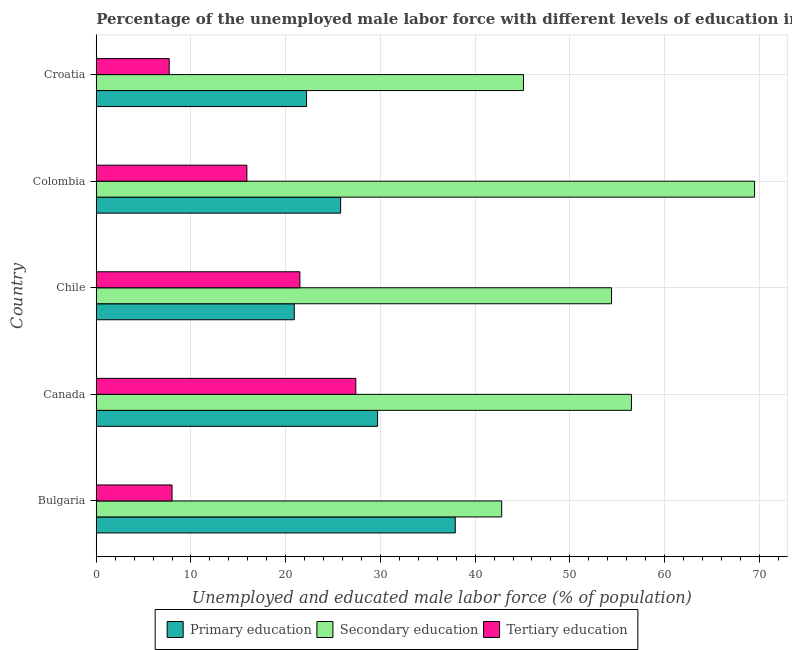How many different coloured bars are there?
Make the answer very short. 3. How many groups of bars are there?
Your answer should be compact. 5. How many bars are there on the 5th tick from the top?
Give a very brief answer. 3. What is the label of the 1st group of bars from the top?
Offer a terse response. Croatia. In how many cases, is the number of bars for a given country not equal to the number of legend labels?
Make the answer very short. 0. What is the percentage of male labor force who received tertiary education in Canada?
Provide a succinct answer. 27.4. Across all countries, what is the maximum percentage of male labor force who received primary education?
Give a very brief answer. 37.9. Across all countries, what is the minimum percentage of male labor force who received secondary education?
Ensure brevity in your answer.  42.8. In which country was the percentage of male labor force who received tertiary education minimum?
Offer a terse response. Croatia. What is the total percentage of male labor force who received tertiary education in the graph?
Provide a short and direct response. 80.5. What is the difference between the percentage of male labor force who received tertiary education in Colombia and the percentage of male labor force who received primary education in Croatia?
Offer a very short reply. -6.3. What is the average percentage of male labor force who received primary education per country?
Your answer should be compact. 27.3. What is the difference between the percentage of male labor force who received tertiary education and percentage of male labor force who received secondary education in Colombia?
Your answer should be compact. -53.6. What is the ratio of the percentage of male labor force who received primary education in Bulgaria to that in Croatia?
Your answer should be very brief. 1.71. What is the difference between the highest and the lowest percentage of male labor force who received primary education?
Your answer should be compact. 17. In how many countries, is the percentage of male labor force who received secondary education greater than the average percentage of male labor force who received secondary education taken over all countries?
Your response must be concise. 3. What does the 2nd bar from the bottom in Canada represents?
Ensure brevity in your answer.  Secondary education. Is it the case that in every country, the sum of the percentage of male labor force who received primary education and percentage of male labor force who received secondary education is greater than the percentage of male labor force who received tertiary education?
Offer a terse response. Yes. How many bars are there?
Offer a terse response. 15. Are all the bars in the graph horizontal?
Make the answer very short. Yes. What is the difference between two consecutive major ticks on the X-axis?
Your response must be concise. 10. Are the values on the major ticks of X-axis written in scientific E-notation?
Provide a succinct answer. No. Where does the legend appear in the graph?
Provide a succinct answer. Bottom center. How many legend labels are there?
Your answer should be very brief. 3. How are the legend labels stacked?
Offer a terse response. Horizontal. What is the title of the graph?
Offer a terse response. Percentage of the unemployed male labor force with different levels of education in countries. What is the label or title of the X-axis?
Ensure brevity in your answer.  Unemployed and educated male labor force (% of population). What is the Unemployed and educated male labor force (% of population) in Primary education in Bulgaria?
Offer a terse response. 37.9. What is the Unemployed and educated male labor force (% of population) in Secondary education in Bulgaria?
Give a very brief answer. 42.8. What is the Unemployed and educated male labor force (% of population) in Tertiary education in Bulgaria?
Offer a very short reply. 8. What is the Unemployed and educated male labor force (% of population) in Primary education in Canada?
Your answer should be very brief. 29.7. What is the Unemployed and educated male labor force (% of population) in Secondary education in Canada?
Ensure brevity in your answer.  56.5. What is the Unemployed and educated male labor force (% of population) in Tertiary education in Canada?
Keep it short and to the point. 27.4. What is the Unemployed and educated male labor force (% of population) in Primary education in Chile?
Give a very brief answer. 20.9. What is the Unemployed and educated male labor force (% of population) in Secondary education in Chile?
Your response must be concise. 54.4. What is the Unemployed and educated male labor force (% of population) in Primary education in Colombia?
Your answer should be compact. 25.8. What is the Unemployed and educated male labor force (% of population) of Secondary education in Colombia?
Provide a short and direct response. 69.5. What is the Unemployed and educated male labor force (% of population) in Tertiary education in Colombia?
Provide a short and direct response. 15.9. What is the Unemployed and educated male labor force (% of population) in Primary education in Croatia?
Provide a succinct answer. 22.2. What is the Unemployed and educated male labor force (% of population) of Secondary education in Croatia?
Ensure brevity in your answer.  45.1. What is the Unemployed and educated male labor force (% of population) in Tertiary education in Croatia?
Give a very brief answer. 7.7. Across all countries, what is the maximum Unemployed and educated male labor force (% of population) of Primary education?
Your answer should be very brief. 37.9. Across all countries, what is the maximum Unemployed and educated male labor force (% of population) in Secondary education?
Make the answer very short. 69.5. Across all countries, what is the maximum Unemployed and educated male labor force (% of population) of Tertiary education?
Give a very brief answer. 27.4. Across all countries, what is the minimum Unemployed and educated male labor force (% of population) of Primary education?
Give a very brief answer. 20.9. Across all countries, what is the minimum Unemployed and educated male labor force (% of population) in Secondary education?
Your answer should be compact. 42.8. Across all countries, what is the minimum Unemployed and educated male labor force (% of population) in Tertiary education?
Your response must be concise. 7.7. What is the total Unemployed and educated male labor force (% of population) in Primary education in the graph?
Provide a short and direct response. 136.5. What is the total Unemployed and educated male labor force (% of population) in Secondary education in the graph?
Offer a terse response. 268.3. What is the total Unemployed and educated male labor force (% of population) of Tertiary education in the graph?
Offer a terse response. 80.5. What is the difference between the Unemployed and educated male labor force (% of population) in Secondary education in Bulgaria and that in Canada?
Offer a very short reply. -13.7. What is the difference between the Unemployed and educated male labor force (% of population) of Tertiary education in Bulgaria and that in Canada?
Provide a succinct answer. -19.4. What is the difference between the Unemployed and educated male labor force (% of population) of Tertiary education in Bulgaria and that in Chile?
Your response must be concise. -13.5. What is the difference between the Unemployed and educated male labor force (% of population) of Secondary education in Bulgaria and that in Colombia?
Provide a succinct answer. -26.7. What is the difference between the Unemployed and educated male labor force (% of population) in Tertiary education in Bulgaria and that in Croatia?
Offer a terse response. 0.3. What is the difference between the Unemployed and educated male labor force (% of population) of Secondary education in Canada and that in Chile?
Your answer should be compact. 2.1. What is the difference between the Unemployed and educated male labor force (% of population) in Tertiary education in Canada and that in Croatia?
Provide a succinct answer. 19.7. What is the difference between the Unemployed and educated male labor force (% of population) in Secondary education in Chile and that in Colombia?
Ensure brevity in your answer.  -15.1. What is the difference between the Unemployed and educated male labor force (% of population) of Primary education in Chile and that in Croatia?
Your answer should be compact. -1.3. What is the difference between the Unemployed and educated male labor force (% of population) in Secondary education in Colombia and that in Croatia?
Provide a succinct answer. 24.4. What is the difference between the Unemployed and educated male labor force (% of population) of Primary education in Bulgaria and the Unemployed and educated male labor force (% of population) of Secondary education in Canada?
Your answer should be very brief. -18.6. What is the difference between the Unemployed and educated male labor force (% of population) of Primary education in Bulgaria and the Unemployed and educated male labor force (% of population) of Secondary education in Chile?
Keep it short and to the point. -16.5. What is the difference between the Unemployed and educated male labor force (% of population) in Secondary education in Bulgaria and the Unemployed and educated male labor force (% of population) in Tertiary education in Chile?
Provide a succinct answer. 21.3. What is the difference between the Unemployed and educated male labor force (% of population) in Primary education in Bulgaria and the Unemployed and educated male labor force (% of population) in Secondary education in Colombia?
Ensure brevity in your answer.  -31.6. What is the difference between the Unemployed and educated male labor force (% of population) of Primary education in Bulgaria and the Unemployed and educated male labor force (% of population) of Tertiary education in Colombia?
Your answer should be compact. 22. What is the difference between the Unemployed and educated male labor force (% of population) in Secondary education in Bulgaria and the Unemployed and educated male labor force (% of population) in Tertiary education in Colombia?
Make the answer very short. 26.9. What is the difference between the Unemployed and educated male labor force (% of population) of Primary education in Bulgaria and the Unemployed and educated male labor force (% of population) of Tertiary education in Croatia?
Offer a terse response. 30.2. What is the difference between the Unemployed and educated male labor force (% of population) of Secondary education in Bulgaria and the Unemployed and educated male labor force (% of population) of Tertiary education in Croatia?
Provide a short and direct response. 35.1. What is the difference between the Unemployed and educated male labor force (% of population) of Primary education in Canada and the Unemployed and educated male labor force (% of population) of Secondary education in Chile?
Keep it short and to the point. -24.7. What is the difference between the Unemployed and educated male labor force (% of population) of Primary education in Canada and the Unemployed and educated male labor force (% of population) of Tertiary education in Chile?
Your answer should be compact. 8.2. What is the difference between the Unemployed and educated male labor force (% of population) of Secondary education in Canada and the Unemployed and educated male labor force (% of population) of Tertiary education in Chile?
Ensure brevity in your answer.  35. What is the difference between the Unemployed and educated male labor force (% of population) of Primary education in Canada and the Unemployed and educated male labor force (% of population) of Secondary education in Colombia?
Your response must be concise. -39.8. What is the difference between the Unemployed and educated male labor force (% of population) in Secondary education in Canada and the Unemployed and educated male labor force (% of population) in Tertiary education in Colombia?
Offer a terse response. 40.6. What is the difference between the Unemployed and educated male labor force (% of population) in Primary education in Canada and the Unemployed and educated male labor force (% of population) in Secondary education in Croatia?
Offer a terse response. -15.4. What is the difference between the Unemployed and educated male labor force (% of population) in Secondary education in Canada and the Unemployed and educated male labor force (% of population) in Tertiary education in Croatia?
Offer a very short reply. 48.8. What is the difference between the Unemployed and educated male labor force (% of population) in Primary education in Chile and the Unemployed and educated male labor force (% of population) in Secondary education in Colombia?
Give a very brief answer. -48.6. What is the difference between the Unemployed and educated male labor force (% of population) in Primary education in Chile and the Unemployed and educated male labor force (% of population) in Tertiary education in Colombia?
Your response must be concise. 5. What is the difference between the Unemployed and educated male labor force (% of population) in Secondary education in Chile and the Unemployed and educated male labor force (% of population) in Tertiary education in Colombia?
Offer a very short reply. 38.5. What is the difference between the Unemployed and educated male labor force (% of population) of Primary education in Chile and the Unemployed and educated male labor force (% of population) of Secondary education in Croatia?
Offer a very short reply. -24.2. What is the difference between the Unemployed and educated male labor force (% of population) of Secondary education in Chile and the Unemployed and educated male labor force (% of population) of Tertiary education in Croatia?
Provide a succinct answer. 46.7. What is the difference between the Unemployed and educated male labor force (% of population) in Primary education in Colombia and the Unemployed and educated male labor force (% of population) in Secondary education in Croatia?
Provide a succinct answer. -19.3. What is the difference between the Unemployed and educated male labor force (% of population) of Secondary education in Colombia and the Unemployed and educated male labor force (% of population) of Tertiary education in Croatia?
Your answer should be very brief. 61.8. What is the average Unemployed and educated male labor force (% of population) in Primary education per country?
Give a very brief answer. 27.3. What is the average Unemployed and educated male labor force (% of population) of Secondary education per country?
Provide a succinct answer. 53.66. What is the difference between the Unemployed and educated male labor force (% of population) in Primary education and Unemployed and educated male labor force (% of population) in Secondary education in Bulgaria?
Provide a short and direct response. -4.9. What is the difference between the Unemployed and educated male labor force (% of population) of Primary education and Unemployed and educated male labor force (% of population) of Tertiary education in Bulgaria?
Your response must be concise. 29.9. What is the difference between the Unemployed and educated male labor force (% of population) in Secondary education and Unemployed and educated male labor force (% of population) in Tertiary education in Bulgaria?
Offer a very short reply. 34.8. What is the difference between the Unemployed and educated male labor force (% of population) of Primary education and Unemployed and educated male labor force (% of population) of Secondary education in Canada?
Offer a terse response. -26.8. What is the difference between the Unemployed and educated male labor force (% of population) of Secondary education and Unemployed and educated male labor force (% of population) of Tertiary education in Canada?
Your answer should be very brief. 29.1. What is the difference between the Unemployed and educated male labor force (% of population) in Primary education and Unemployed and educated male labor force (% of population) in Secondary education in Chile?
Offer a terse response. -33.5. What is the difference between the Unemployed and educated male labor force (% of population) of Primary education and Unemployed and educated male labor force (% of population) of Tertiary education in Chile?
Your answer should be very brief. -0.6. What is the difference between the Unemployed and educated male labor force (% of population) of Secondary education and Unemployed and educated male labor force (% of population) of Tertiary education in Chile?
Make the answer very short. 32.9. What is the difference between the Unemployed and educated male labor force (% of population) of Primary education and Unemployed and educated male labor force (% of population) of Secondary education in Colombia?
Your response must be concise. -43.7. What is the difference between the Unemployed and educated male labor force (% of population) in Primary education and Unemployed and educated male labor force (% of population) in Tertiary education in Colombia?
Provide a succinct answer. 9.9. What is the difference between the Unemployed and educated male labor force (% of population) in Secondary education and Unemployed and educated male labor force (% of population) in Tertiary education in Colombia?
Offer a very short reply. 53.6. What is the difference between the Unemployed and educated male labor force (% of population) of Primary education and Unemployed and educated male labor force (% of population) of Secondary education in Croatia?
Offer a very short reply. -22.9. What is the difference between the Unemployed and educated male labor force (% of population) of Secondary education and Unemployed and educated male labor force (% of population) of Tertiary education in Croatia?
Your answer should be compact. 37.4. What is the ratio of the Unemployed and educated male labor force (% of population) of Primary education in Bulgaria to that in Canada?
Give a very brief answer. 1.28. What is the ratio of the Unemployed and educated male labor force (% of population) in Secondary education in Bulgaria to that in Canada?
Give a very brief answer. 0.76. What is the ratio of the Unemployed and educated male labor force (% of population) in Tertiary education in Bulgaria to that in Canada?
Provide a short and direct response. 0.29. What is the ratio of the Unemployed and educated male labor force (% of population) of Primary education in Bulgaria to that in Chile?
Your answer should be compact. 1.81. What is the ratio of the Unemployed and educated male labor force (% of population) in Secondary education in Bulgaria to that in Chile?
Provide a short and direct response. 0.79. What is the ratio of the Unemployed and educated male labor force (% of population) of Tertiary education in Bulgaria to that in Chile?
Provide a short and direct response. 0.37. What is the ratio of the Unemployed and educated male labor force (% of population) of Primary education in Bulgaria to that in Colombia?
Provide a succinct answer. 1.47. What is the ratio of the Unemployed and educated male labor force (% of population) in Secondary education in Bulgaria to that in Colombia?
Provide a succinct answer. 0.62. What is the ratio of the Unemployed and educated male labor force (% of population) in Tertiary education in Bulgaria to that in Colombia?
Your response must be concise. 0.5. What is the ratio of the Unemployed and educated male labor force (% of population) in Primary education in Bulgaria to that in Croatia?
Provide a short and direct response. 1.71. What is the ratio of the Unemployed and educated male labor force (% of population) in Secondary education in Bulgaria to that in Croatia?
Provide a short and direct response. 0.95. What is the ratio of the Unemployed and educated male labor force (% of population) of Tertiary education in Bulgaria to that in Croatia?
Your response must be concise. 1.04. What is the ratio of the Unemployed and educated male labor force (% of population) of Primary education in Canada to that in Chile?
Provide a succinct answer. 1.42. What is the ratio of the Unemployed and educated male labor force (% of population) of Secondary education in Canada to that in Chile?
Your answer should be very brief. 1.04. What is the ratio of the Unemployed and educated male labor force (% of population) in Tertiary education in Canada to that in Chile?
Offer a very short reply. 1.27. What is the ratio of the Unemployed and educated male labor force (% of population) in Primary education in Canada to that in Colombia?
Your answer should be very brief. 1.15. What is the ratio of the Unemployed and educated male labor force (% of population) of Secondary education in Canada to that in Colombia?
Your answer should be compact. 0.81. What is the ratio of the Unemployed and educated male labor force (% of population) of Tertiary education in Canada to that in Colombia?
Make the answer very short. 1.72. What is the ratio of the Unemployed and educated male labor force (% of population) of Primary education in Canada to that in Croatia?
Make the answer very short. 1.34. What is the ratio of the Unemployed and educated male labor force (% of population) in Secondary education in Canada to that in Croatia?
Offer a terse response. 1.25. What is the ratio of the Unemployed and educated male labor force (% of population) in Tertiary education in Canada to that in Croatia?
Your response must be concise. 3.56. What is the ratio of the Unemployed and educated male labor force (% of population) of Primary education in Chile to that in Colombia?
Give a very brief answer. 0.81. What is the ratio of the Unemployed and educated male labor force (% of population) of Secondary education in Chile to that in Colombia?
Offer a terse response. 0.78. What is the ratio of the Unemployed and educated male labor force (% of population) in Tertiary education in Chile to that in Colombia?
Give a very brief answer. 1.35. What is the ratio of the Unemployed and educated male labor force (% of population) of Primary education in Chile to that in Croatia?
Provide a short and direct response. 0.94. What is the ratio of the Unemployed and educated male labor force (% of population) in Secondary education in Chile to that in Croatia?
Offer a terse response. 1.21. What is the ratio of the Unemployed and educated male labor force (% of population) of Tertiary education in Chile to that in Croatia?
Provide a short and direct response. 2.79. What is the ratio of the Unemployed and educated male labor force (% of population) of Primary education in Colombia to that in Croatia?
Give a very brief answer. 1.16. What is the ratio of the Unemployed and educated male labor force (% of population) in Secondary education in Colombia to that in Croatia?
Offer a very short reply. 1.54. What is the ratio of the Unemployed and educated male labor force (% of population) in Tertiary education in Colombia to that in Croatia?
Offer a very short reply. 2.06. What is the difference between the highest and the second highest Unemployed and educated male labor force (% of population) in Primary education?
Your response must be concise. 8.2. What is the difference between the highest and the second highest Unemployed and educated male labor force (% of population) in Secondary education?
Ensure brevity in your answer.  13. What is the difference between the highest and the lowest Unemployed and educated male labor force (% of population) in Secondary education?
Keep it short and to the point. 26.7. What is the difference between the highest and the lowest Unemployed and educated male labor force (% of population) in Tertiary education?
Your answer should be compact. 19.7. 